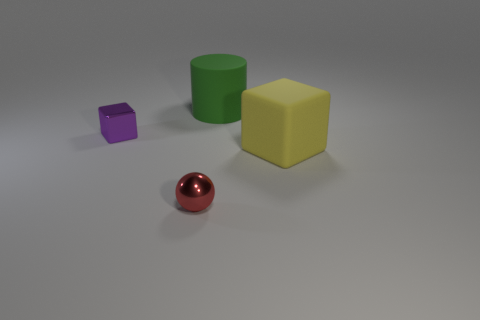Add 1 tiny cyan things. How many objects exist? 5 Subtract all purple cubes. How many cubes are left? 1 Subtract all spheres. How many objects are left? 3 Subtract 1 balls. How many balls are left? 0 Subtract all brown cubes. Subtract all purple cylinders. How many cubes are left? 2 Subtract all brown cylinders. How many green blocks are left? 0 Subtract all large blue rubber cubes. Subtract all green objects. How many objects are left? 3 Add 4 cylinders. How many cylinders are left? 5 Add 2 tiny purple cubes. How many tiny purple cubes exist? 3 Subtract 0 cyan cylinders. How many objects are left? 4 